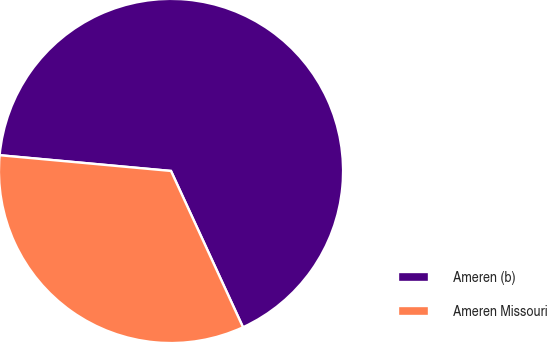Convert chart. <chart><loc_0><loc_0><loc_500><loc_500><pie_chart><fcel>Ameren (b)<fcel>Ameren Missouri<nl><fcel>66.67%<fcel>33.33%<nl></chart> 